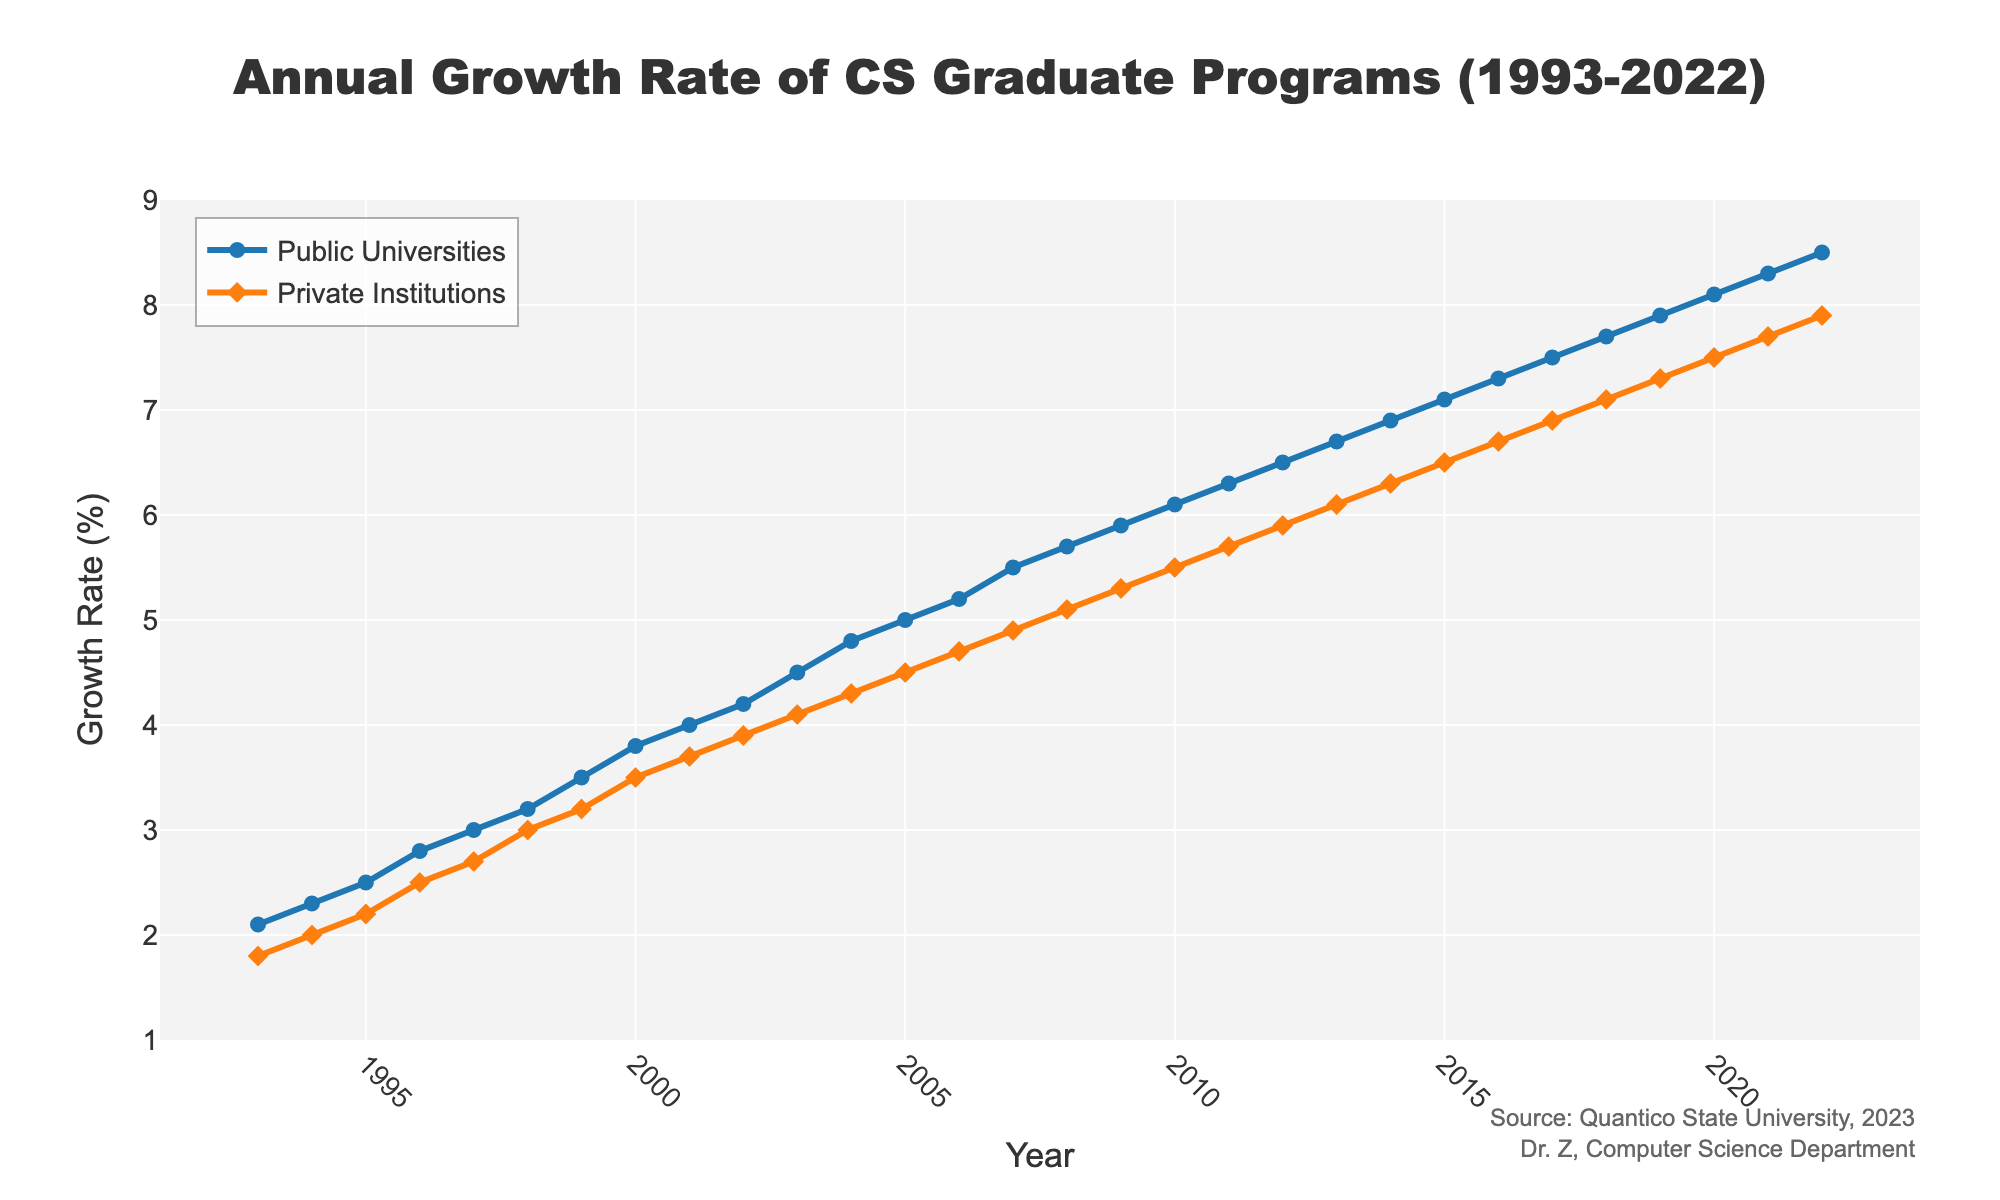What year did the growth rate of computer science graduate programs at public universities first surpass 5%? By observing the line for public universities, you can see that it crosses the 5% growth rate mark between 2004 and 2005. Hence, the first year it surpasses 5% is 2005.
Answer: 2005 By how much did the growth rate increase for private institutions from 1993 to 2022? The growth rate for private institutions was 1.8% in 1993 and increased to 7.9% in 2022. The increase is calculated by subtracting the initial value from the final value: 7.9 - 1.8.
Answer: 6.1% Which type of institution had a higher growth rate in the year 2010? Referring to the values for both institutions in 2010, public universities had a growth rate of 6.1% while private institutions had a growth rate of 5.5%. Therefore, public universities had a higher growth rate.
Answer: Public universities Identify the year when the growth rate of computer science graduate programs at private institutions reached 7%. By examining the line for private institutions, you see that the growth rate reaches 7% in 2018.
Answer: 2018 During the period from 1997 to 2001, what was the average annual growth rate for public universities? The growth rates for public universities from 1997 to 2001 are 3.0, 3.2, 3.5, 3.8, and 4.0 respectively. The average is calculated as (3.0 + 3.2 + 3.5 + 3.8 + 4.0) / 5.
Answer: 3.5% In which year was the difference between the growth rates of public universities and private institutions the smallest? For each year, compute the absolute difference between the growth rates of public universities and private institutions, and identify the year with the smallest difference. By comparison, the year 2022 has the smallest difference (8.5% - 7.9% = 0.6%).
Answer: 2022 What color represents the growth rate of private institutions in the plot? By referring to the visual attributes of the plot, private institutions are represented by an orange-colored line.
Answer: Orange 